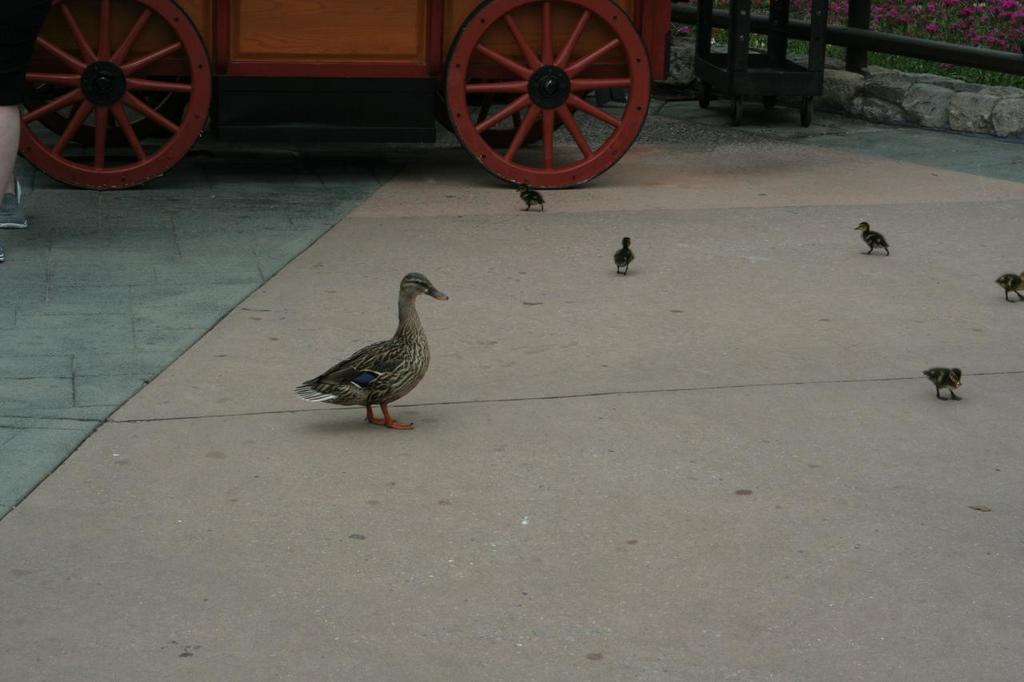What type of animals can be seen on the surface in the image? There are birds on the surface in the image. What objects are present in the image that might be used for transportation or carrying items? There are carts in the image. What other objects can be seen in the image? There are rods in the image. What can be seen in the background of the image? There are flowers visible in the background of the image. What type of notebook is being used to improve the acoustics in the image? There is no notebook or mention of acoustics in the image; it features birds, carts, rods, and flowers. 